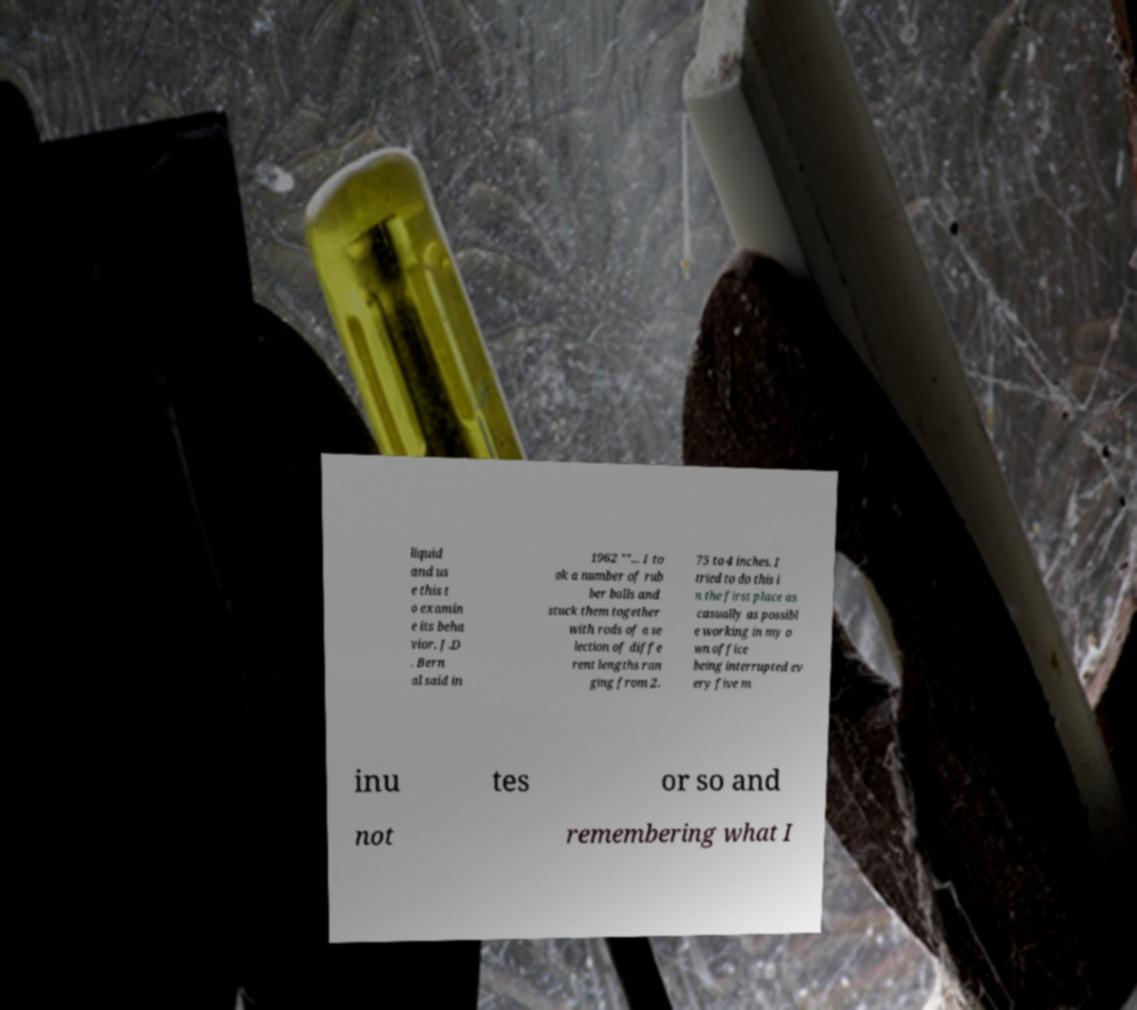Can you accurately transcribe the text from the provided image for me? liquid and us e this t o examin e its beha vior. J.D . Bern al said in 1962 ""... I to ok a number of rub ber balls and stuck them together with rods of a se lection of diffe rent lengths ran ging from 2. 75 to 4 inches. I tried to do this i n the first place as casually as possibl e working in my o wn office being interrupted ev ery five m inu tes or so and not remembering what I 